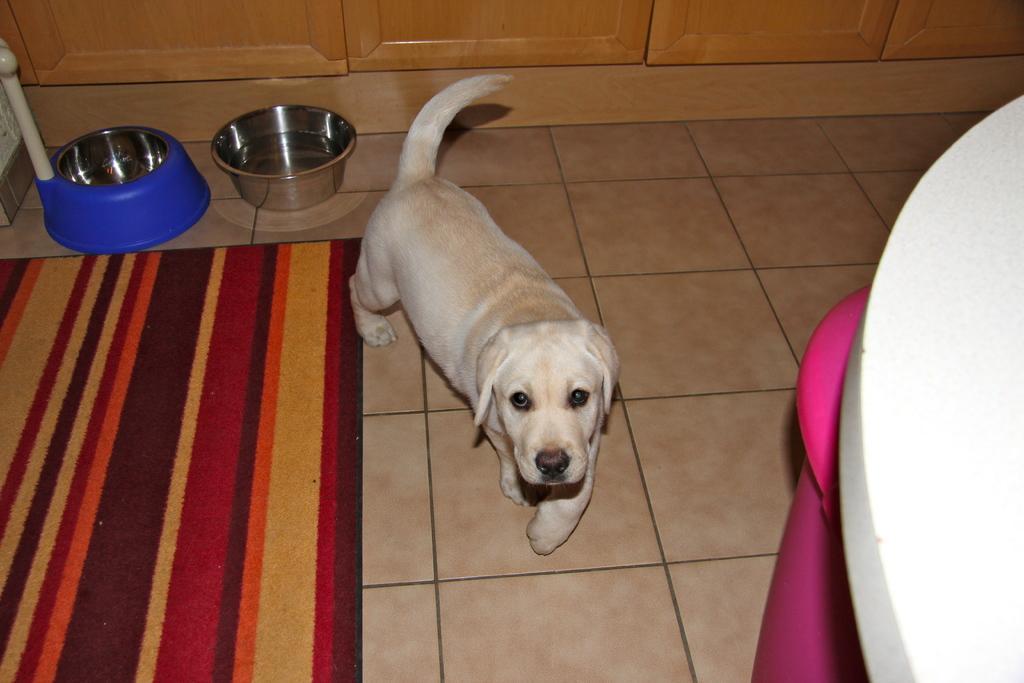Describe this image in one or two sentences. In this image, we can see a white dog on the floor. Here there is a floor mat. Right side of the image, we can see white and pink color object. Top of the image, we can see wooden boards and steel bowls. 